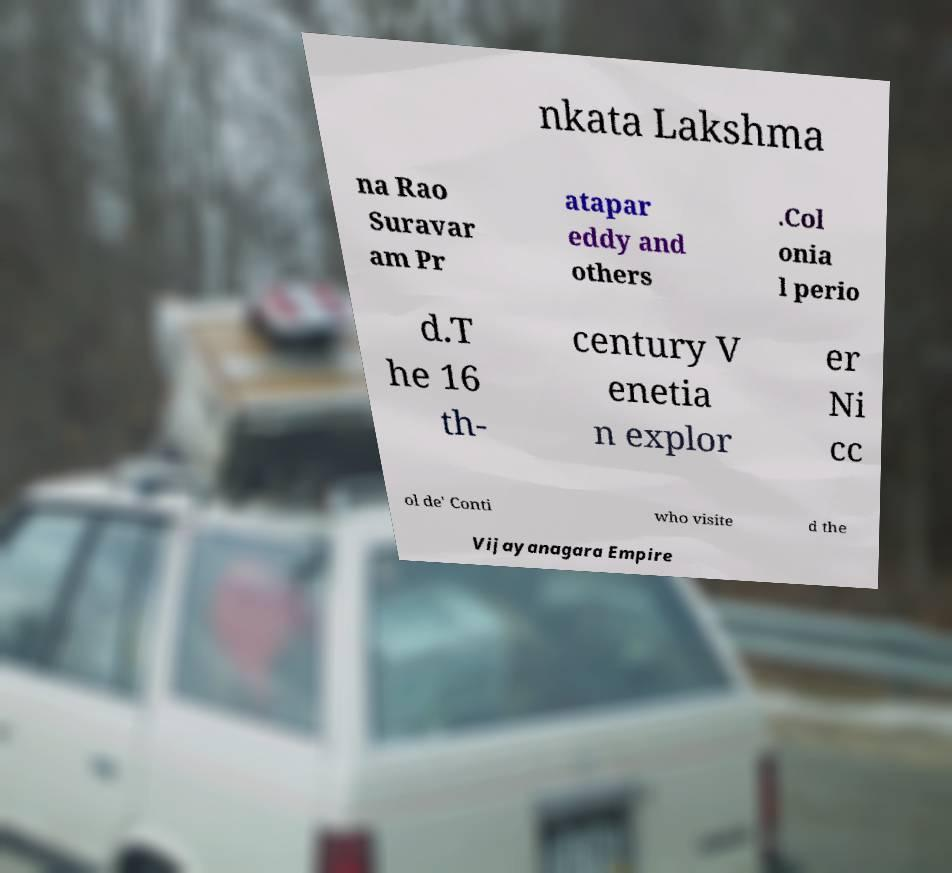I need the written content from this picture converted into text. Can you do that? nkata Lakshma na Rao Suravar am Pr atapar eddy and others .Col onia l perio d.T he 16 th- century V enetia n explor er Ni cc ol de' Conti who visite d the Vijayanagara Empire 